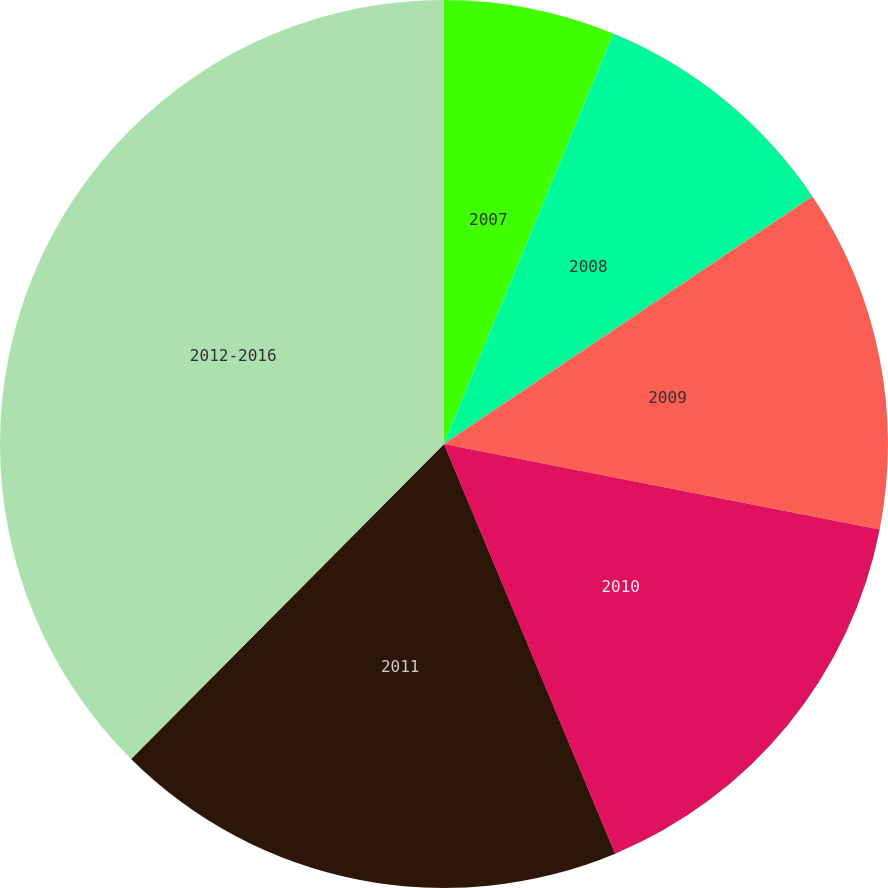Convert chart. <chart><loc_0><loc_0><loc_500><loc_500><pie_chart><fcel>2007<fcel>2008<fcel>2009<fcel>2010<fcel>2011<fcel>2012-2016<nl><fcel>6.23%<fcel>9.36%<fcel>12.49%<fcel>15.62%<fcel>18.75%<fcel>37.55%<nl></chart> 